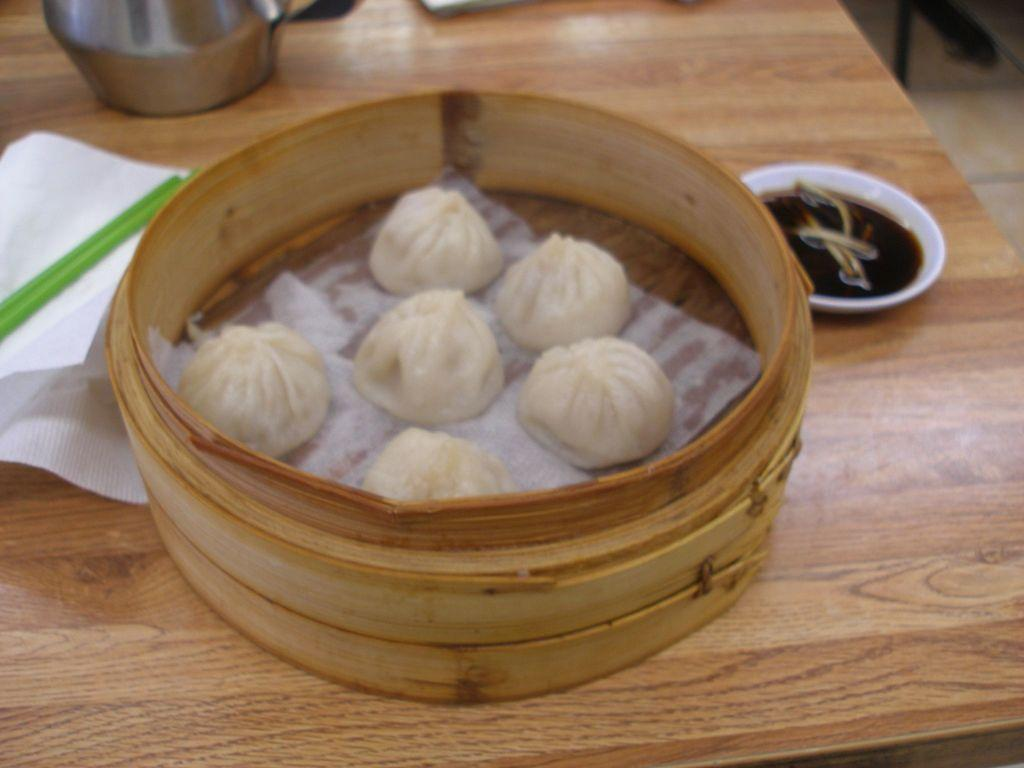What type of eatables are placed in the wooden object? The facts do not specify the type of eatables placed in the wooden object. Where is the wooden object located? The wooden object is on a table. What else can be seen on the table? The facts mention that there are other objects on the table, but their specifics are not provided. What channel is the game being played on in the image? There is no mention of a game or a channel in the provided facts, so this question cannot be answered. 